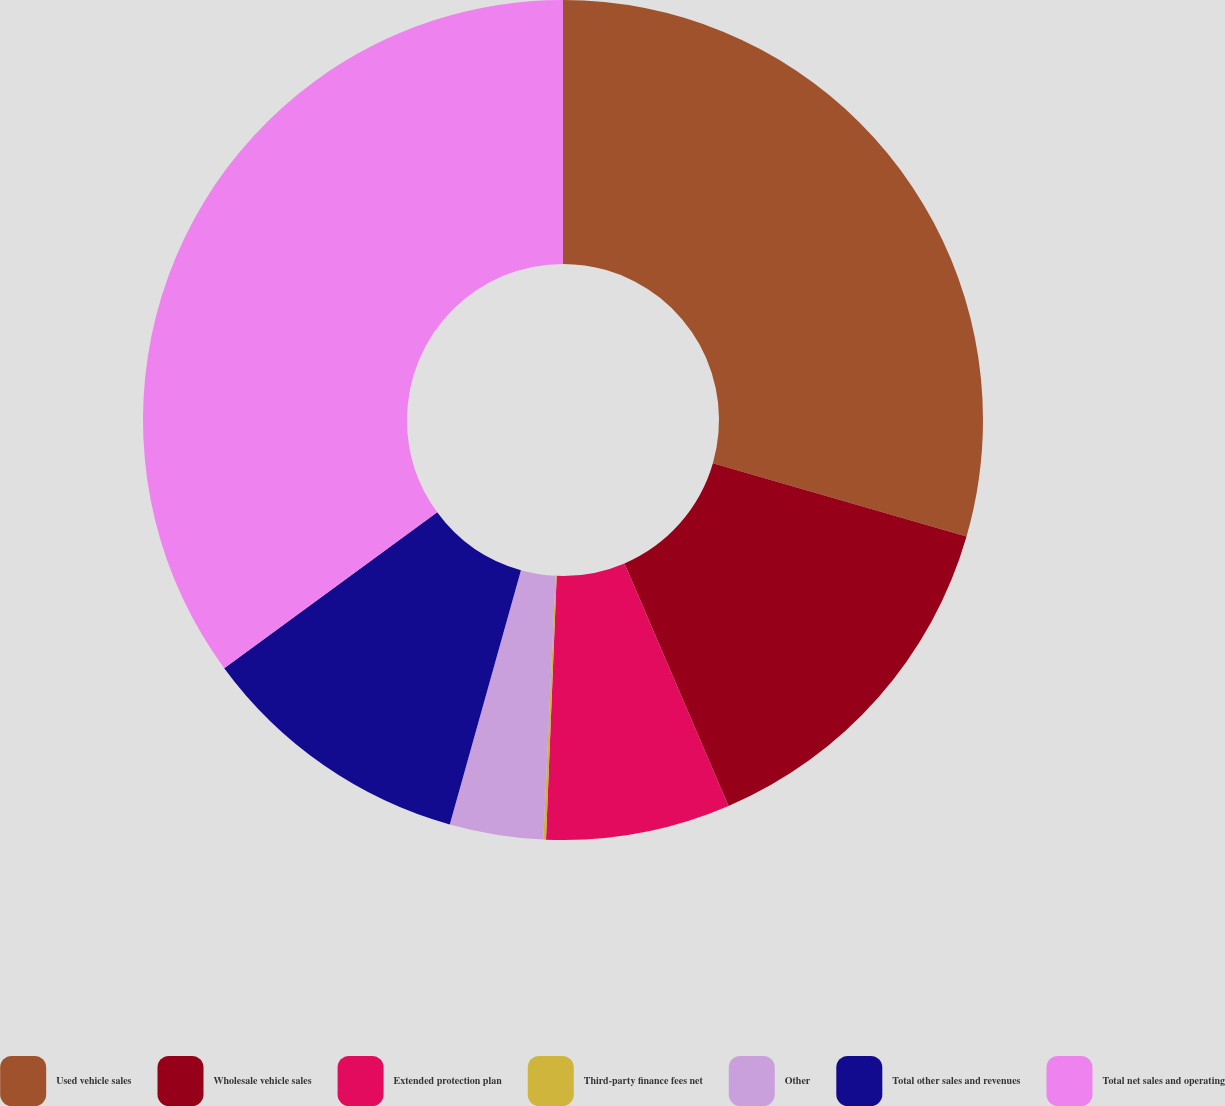Convert chart to OTSL. <chart><loc_0><loc_0><loc_500><loc_500><pie_chart><fcel>Used vehicle sales<fcel>Wholesale vehicle sales<fcel>Extended protection plan<fcel>Third-party finance fees net<fcel>Other<fcel>Total other sales and revenues<fcel>Total net sales and operating<nl><fcel>29.47%<fcel>14.08%<fcel>7.09%<fcel>0.1%<fcel>3.6%<fcel>10.59%<fcel>35.06%<nl></chart> 